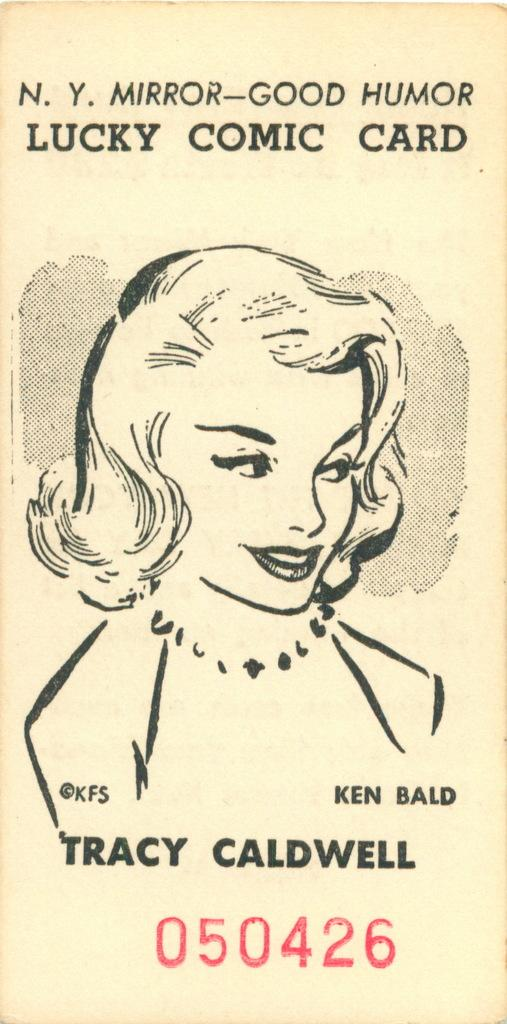What is the main object in the image? There is a pamphlet in the image. What can be seen on the pamphlet? The pamphlet contains a lady's image. Are there any identifiers on the pamphlet? Yes, there is a serial number and a person's name on the pamphlet. What grade of yarn is used to create the pamphlet? There is no yarn mentioned or used in the creation of the pamphlet; it is a printed document. How is the pamphlet measured in the image? The pamphlet is not being measured in the image; it is simply displayed. 